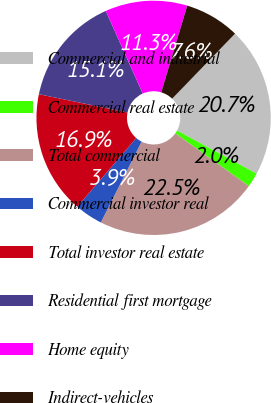Convert chart. <chart><loc_0><loc_0><loc_500><loc_500><pie_chart><fcel>Commercial and industrial<fcel>Commercial real estate<fcel>Total commercial<fcel>Commercial investor real<fcel>Total investor real estate<fcel>Residential first mortgage<fcel>Home equity<fcel>Indirect-vehicles<nl><fcel>20.67%<fcel>1.99%<fcel>22.54%<fcel>3.86%<fcel>16.94%<fcel>15.07%<fcel>11.33%<fcel>7.6%<nl></chart> 